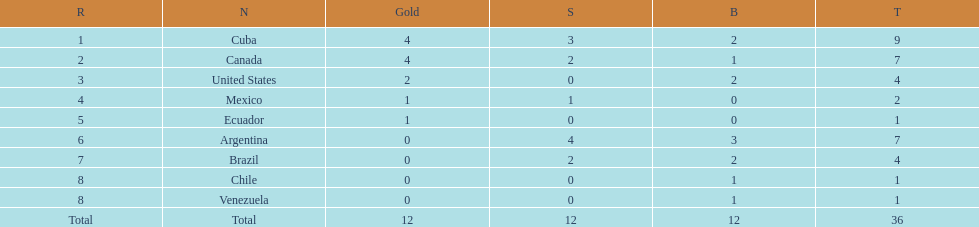Which country won the largest haul of bronze medals? Argentina. 